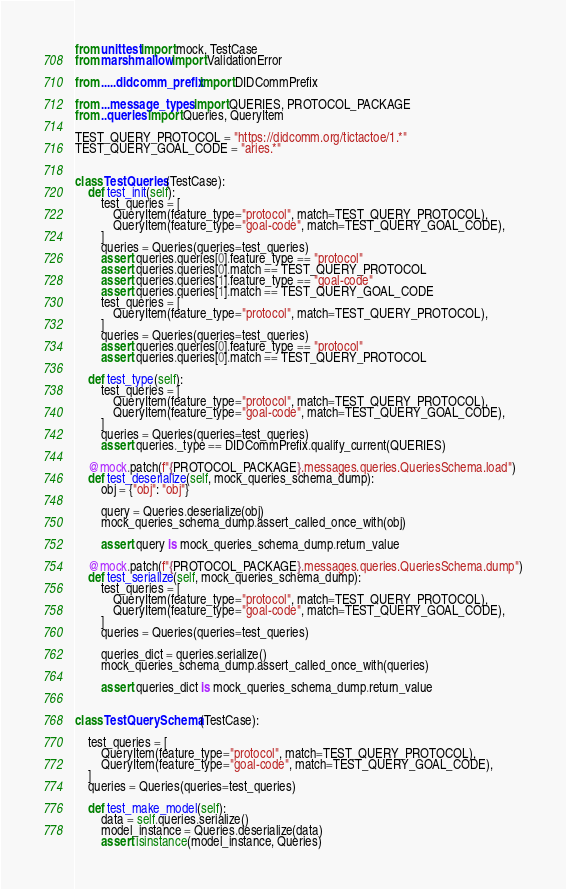<code> <loc_0><loc_0><loc_500><loc_500><_Python_>from unittest import mock, TestCase
from marshmallow import ValidationError

from .....didcomm_prefix import DIDCommPrefix

from ...message_types import QUERIES, PROTOCOL_PACKAGE
from ..queries import Queries, QueryItem

TEST_QUERY_PROTOCOL = "https://didcomm.org/tictactoe/1.*"
TEST_QUERY_GOAL_CODE = "aries.*"


class TestQueries(TestCase):
    def test_init(self):
        test_queries = [
            QueryItem(feature_type="protocol", match=TEST_QUERY_PROTOCOL),
            QueryItem(feature_type="goal-code", match=TEST_QUERY_GOAL_CODE),
        ]
        queries = Queries(queries=test_queries)
        assert queries.queries[0].feature_type == "protocol"
        assert queries.queries[0].match == TEST_QUERY_PROTOCOL
        assert queries.queries[1].feature_type == "goal-code"
        assert queries.queries[1].match == TEST_QUERY_GOAL_CODE
        test_queries = [
            QueryItem(feature_type="protocol", match=TEST_QUERY_PROTOCOL),
        ]
        queries = Queries(queries=test_queries)
        assert queries.queries[0].feature_type == "protocol"
        assert queries.queries[0].match == TEST_QUERY_PROTOCOL

    def test_type(self):
        test_queries = [
            QueryItem(feature_type="protocol", match=TEST_QUERY_PROTOCOL),
            QueryItem(feature_type="goal-code", match=TEST_QUERY_GOAL_CODE),
        ]
        queries = Queries(queries=test_queries)
        assert queries._type == DIDCommPrefix.qualify_current(QUERIES)

    @mock.patch(f"{PROTOCOL_PACKAGE}.messages.queries.QueriesSchema.load")
    def test_deserialize(self, mock_queries_schema_dump):
        obj = {"obj": "obj"}

        query = Queries.deserialize(obj)
        mock_queries_schema_dump.assert_called_once_with(obj)

        assert query is mock_queries_schema_dump.return_value

    @mock.patch(f"{PROTOCOL_PACKAGE}.messages.queries.QueriesSchema.dump")
    def test_serialize(self, mock_queries_schema_dump):
        test_queries = [
            QueryItem(feature_type="protocol", match=TEST_QUERY_PROTOCOL),
            QueryItem(feature_type="goal-code", match=TEST_QUERY_GOAL_CODE),
        ]
        queries = Queries(queries=test_queries)

        queries_dict = queries.serialize()
        mock_queries_schema_dump.assert_called_once_with(queries)

        assert queries_dict is mock_queries_schema_dump.return_value


class TestQuerySchema(TestCase):

    test_queries = [
        QueryItem(feature_type="protocol", match=TEST_QUERY_PROTOCOL),
        QueryItem(feature_type="goal-code", match=TEST_QUERY_GOAL_CODE),
    ]
    queries = Queries(queries=test_queries)

    def test_make_model(self):
        data = self.queries.serialize()
        model_instance = Queries.deserialize(data)
        assert isinstance(model_instance, Queries)
</code> 